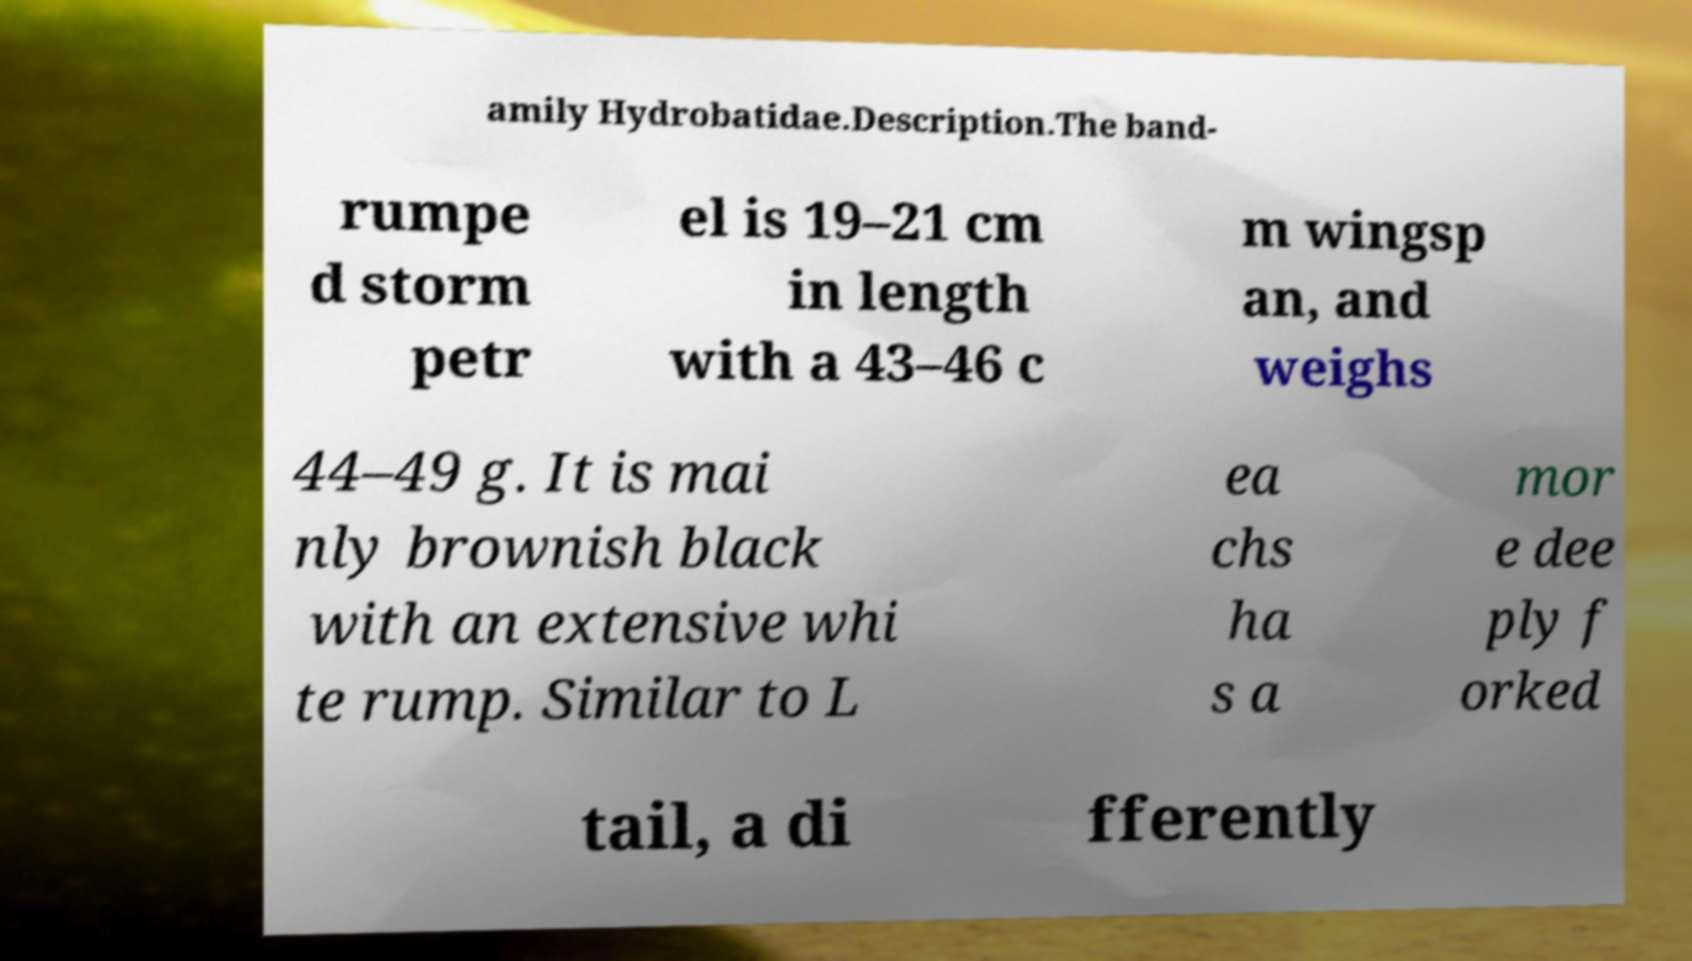Can you accurately transcribe the text from the provided image for me? amily Hydrobatidae.Description.The band- rumpe d storm petr el is 19–21 cm in length with a 43–46 c m wingsp an, and weighs 44–49 g. It is mai nly brownish black with an extensive whi te rump. Similar to L ea chs ha s a mor e dee ply f orked tail, a di fferently 